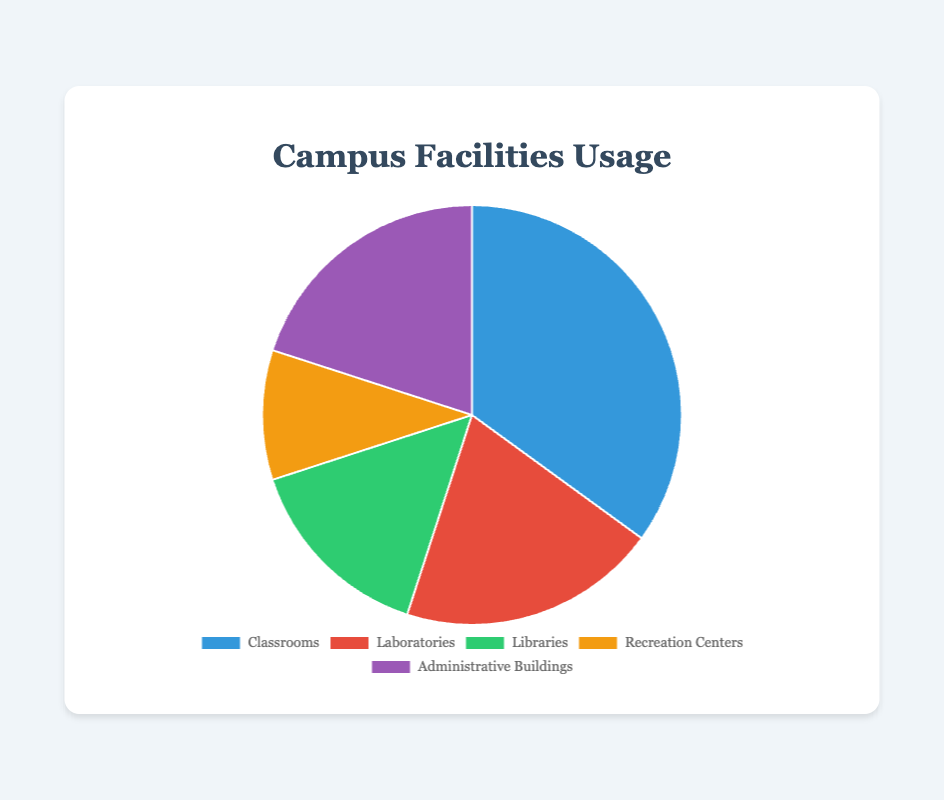What facility is most used on campus? The figure shows the usage percentages of different facilities. Classrooms have the highest usage at 35%.
Answer: Classrooms What is the combined usage percentage of Laboratories and Administrative Buildings? Add the percentages for Laboratories (20%) and Administrative Buildings (20%): 20% + 20% = 40%.
Answer: 40% Which facility has the lowest usage, and what is its percentage? The figure shows various usage percentages. Recreation Centers have the lowest at 10%.
Answer: Recreation Centers, 10% How much more are Classrooms used compared to Recreation Centers? Subtract the usage percentage of Recreation Centers (10%) from Classrooms (35%): 35% - 10% = 25%.
Answer: 25% Are Libraries used more or less than Laboratories? The figure indicates that Libraries have a usage of 15%, while Laboratories have 20%. Libraries are used less than Laboratories.
Answer: Less What is the average usage percentage across all facilities? Add up all usage percentages and divide by the number of facilities: (35% + 20% + 15% + 10% + 20%) / 5 = 100% / 5 = 20%.
Answer: 20% Which facilities have equal usage percentages, and what is the percentage? Both Laboratories and Administrative Buildings have a usage percentage of 20%.
Answer: Laboratories and Administrative Buildings, 20% How much more is the combined usage of Classrooms and Libraries than Recreation Centers and Laboratories? First, calculate the combined usage of Classrooms and Libraries: 35% + 15% = 50%. Next, calculate the combined usage of Recreation Centers and Laboratories: 10% + 20% = 30%. Finally, subtract the second sum from the first: 50% - 30% = 20%.
Answer: 20% How many facilities have a usage percentage of 20% or more? Classrooms (35%), Laboratories (20%), and Administrative Buildings (20%). There are 3 facilities in total.
Answer: 3 